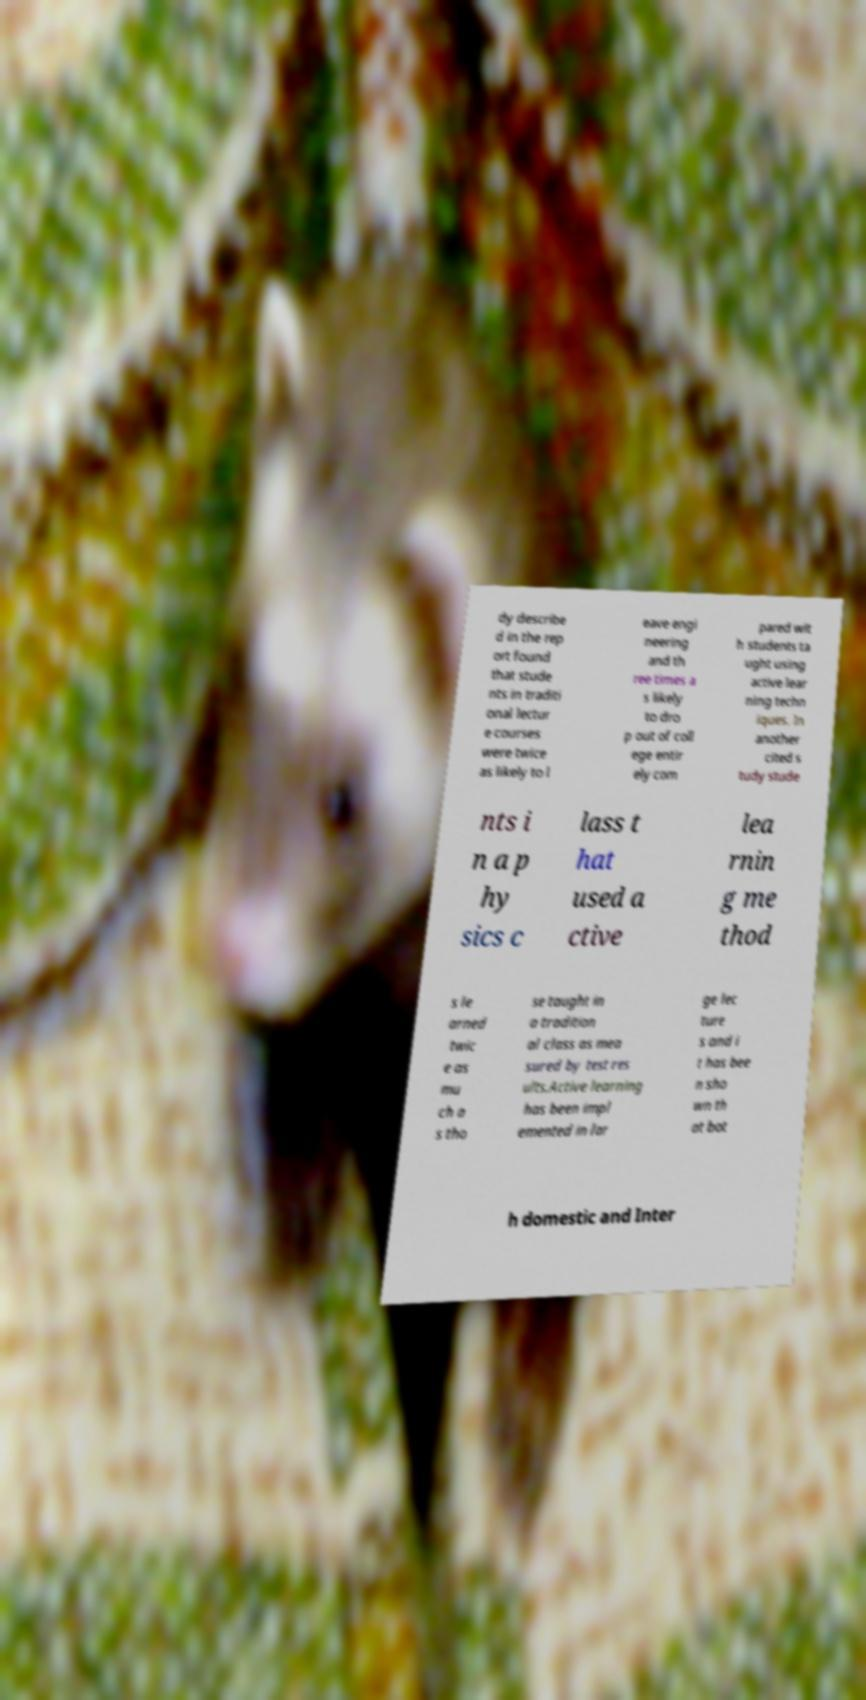Please read and relay the text visible in this image. What does it say? dy describe d in the rep ort found that stude nts in traditi onal lectur e courses were twice as likely to l eave engi neering and th ree times a s likely to dro p out of coll ege entir ely com pared wit h students ta ught using active lear ning techn iques. In another cited s tudy stude nts i n a p hy sics c lass t hat used a ctive lea rnin g me thod s le arned twic e as mu ch a s tho se taught in a tradition al class as mea sured by test res ults.Active learning has been impl emented in lar ge lec ture s and i t has bee n sho wn th at bot h domestic and Inter 